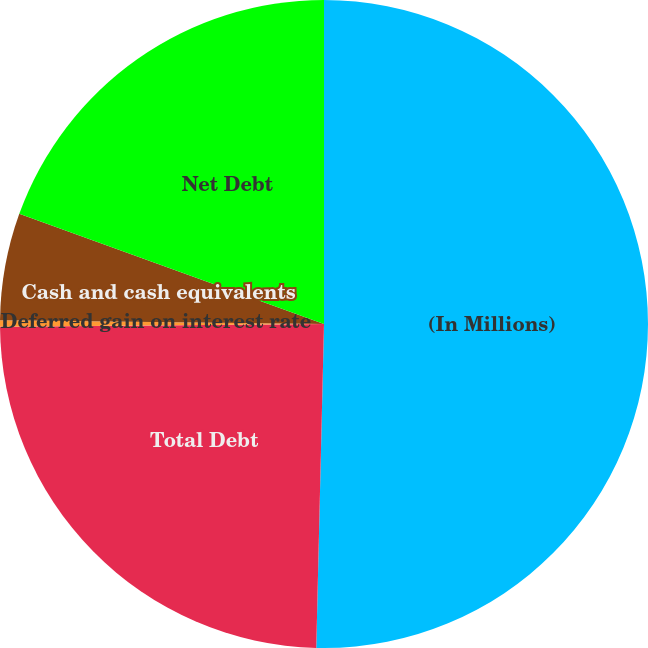Convert chart to OTSL. <chart><loc_0><loc_0><loc_500><loc_500><pie_chart><fcel>(In Millions)<fcel>Total Debt<fcel>Deferred gain on interest rate<fcel>Cash and cash equivalents<fcel>Net Debt<nl><fcel>50.38%<fcel>24.49%<fcel>0.32%<fcel>5.33%<fcel>19.48%<nl></chart> 